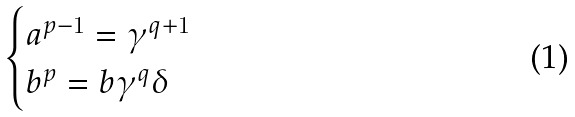<formula> <loc_0><loc_0><loc_500><loc_500>\begin{cases} a ^ { p - 1 } = \gamma ^ { q + 1 } \\ b ^ { p } = b \gamma ^ { q } \delta \\ \end{cases}</formula> 